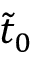Convert formula to latex. <formula><loc_0><loc_0><loc_500><loc_500>\tilde { t } _ { 0 }</formula> 